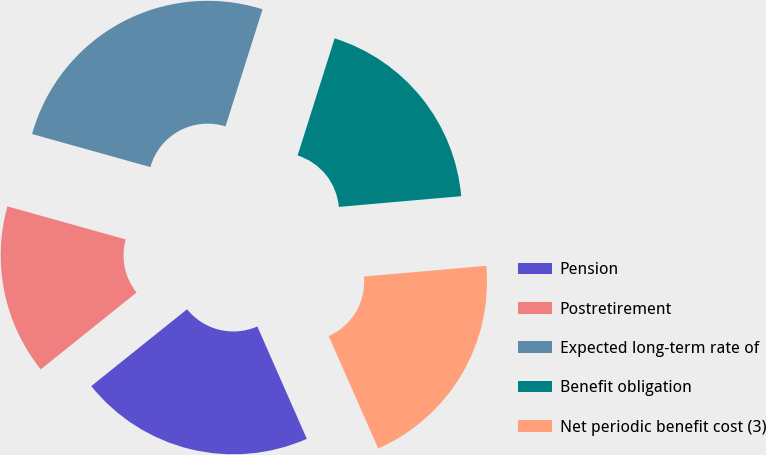<chart> <loc_0><loc_0><loc_500><loc_500><pie_chart><fcel>Pension<fcel>Postretirement<fcel>Expected long-term rate of<fcel>Benefit obligation<fcel>Net periodic benefit cost (3)<nl><fcel>20.84%<fcel>15.09%<fcel>25.54%<fcel>18.73%<fcel>19.79%<nl></chart> 